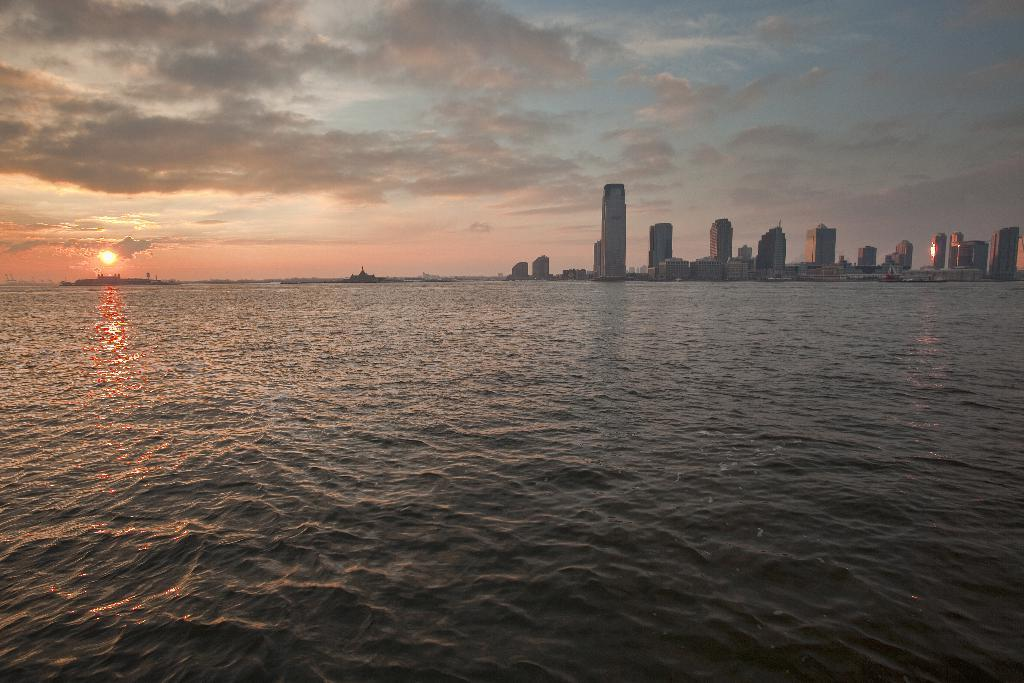What type of natural feature is present in the image? There is a river in the image. What structures can be seen on the right side of the image? There are buildings on the right side of the image. What celestial body is visible in the sky on the left side of the image? The sun is visible in the sky on the left side of the image. What type of lead can be seen in the image? There is no lead present in the image. How many wrens can be seen in the image? There are no wrens present in the image. 